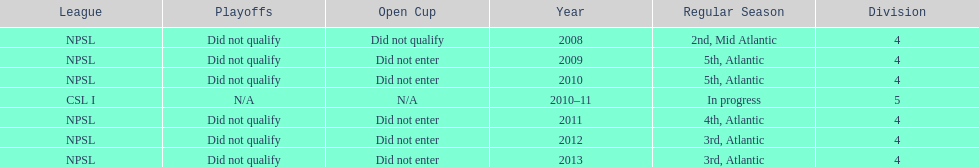Using the data, what should be the next year they will play? 2014. 